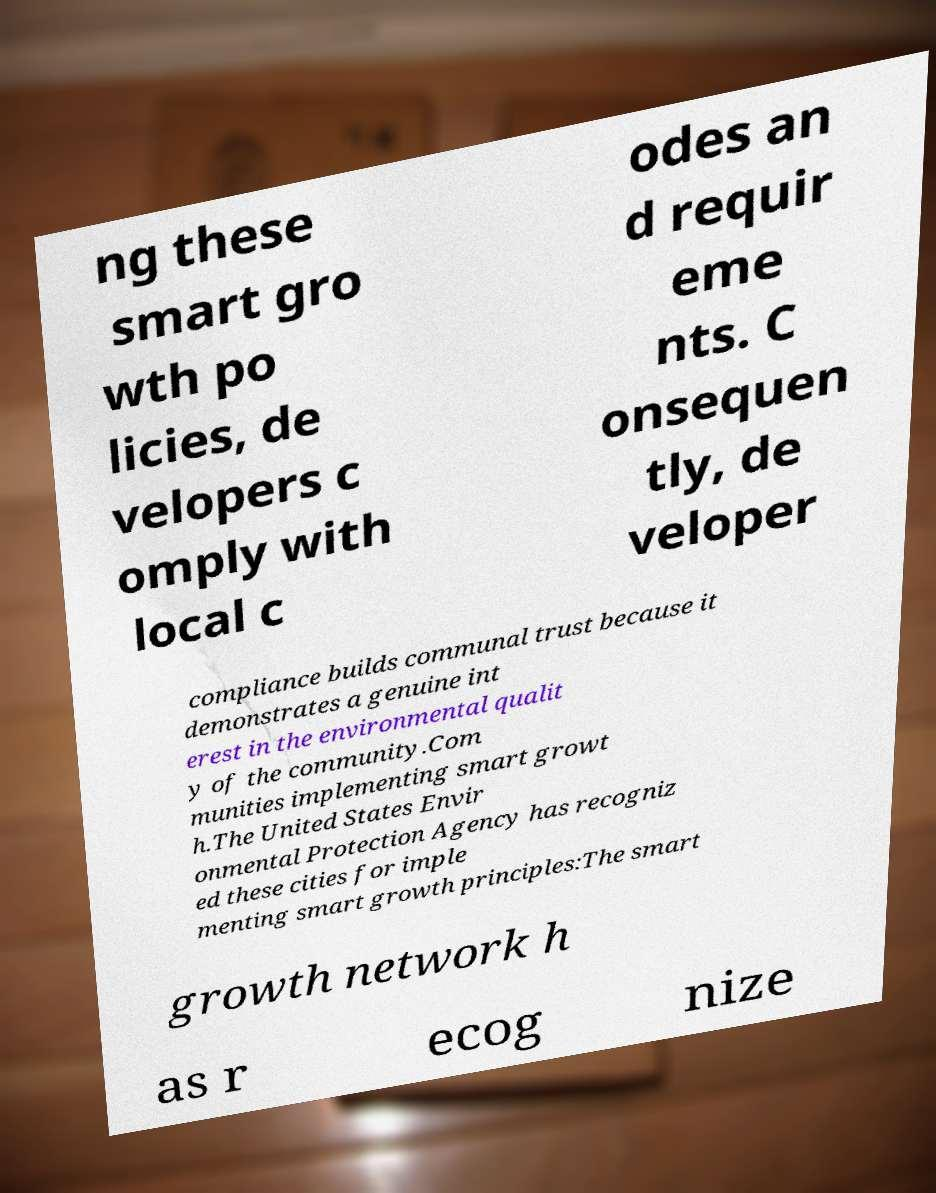Can you accurately transcribe the text from the provided image for me? ng these smart gro wth po licies, de velopers c omply with local c odes an d requir eme nts. C onsequen tly, de veloper compliance builds communal trust because it demonstrates a genuine int erest in the environmental qualit y of the community.Com munities implementing smart growt h.The United States Envir onmental Protection Agency has recogniz ed these cities for imple menting smart growth principles:The smart growth network h as r ecog nize 